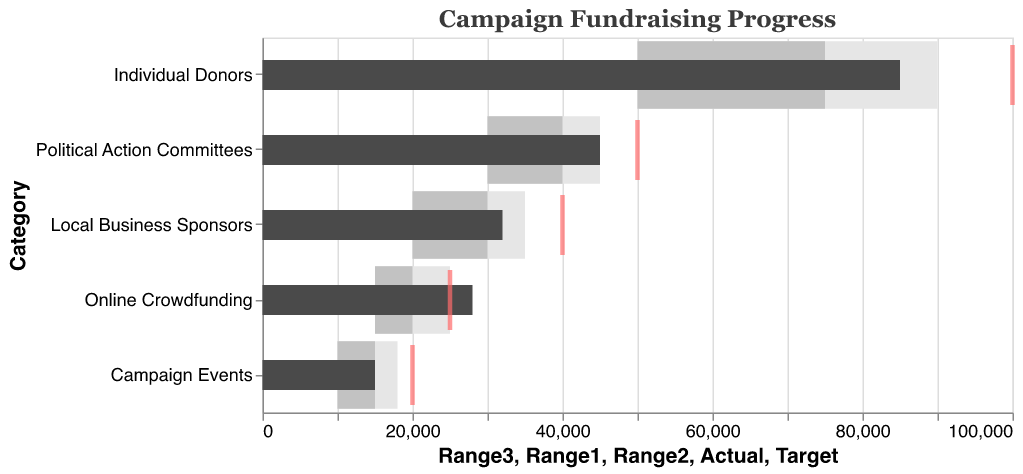What's the overall title of the chart? The title of the chart is displayed at the top and provides a summary of the displayed data. It reads "Campaign Fundraising Progress."
Answer: Campaign Fundraising Progress What color is used for representing the "Actual" values in the chart? The "Actual" values are displayed as bars with a dark shade. Specifically, they are represented with a dark gray color.
Answer: Dark gray Which donation source has the highest actual fundraising amount? By comparing the lengths of the dark gray bars, we can see that "Individual Donors" has the longest bar, indicating the highest actual fundraising amount of 85,000.
Answer: Individual Donors Did "Online Crowdfunding" exceed its target? The actual value bar for "Online Crowdfunding" exceeds the target position marked by the red tick, suggesting that it did exceed its target.
Answer: Yes How many donation sources have actual amounts above their "Range3" values? By looking at the bars and comparing them with the "Range3" values, "Online Crowdfunding" and "Individual Donors" have actual amounts above their "Range3" values.
Answer: Two What is the difference between the actual and target values for "Political Action Committees"? The difference is calculated by subtracting the target value from the actual value: 45000 (Actual) - 50000 (Target) = -5000.
Answer: -5000 Which donation source has the closest actual fundraising amount to its target? By comparing the positions of the dark gray bars with their respective red ticks, "Online Crowdfunding" appears to be almost aligned with the target, making it have the closest actual amount to its target.
Answer: Online Crowdfunding Among the donation sources, which one has the largest difference between "Range2" and "Range1"? To find this, we need to check the difference for each category: "Individual Donors" (75000 - 50000 = 25000), "Local Business Sponsors" (30000 - 20000 = 10000), "Online Crowdfunding" (20000 - 15000 = 5000), "Campaign Events" (15000 - 10000 = 5000), and "Political Action Committees" (40000 - 30000 = 10000). The largest difference is for "Individual Donors."
Answer: Individual Donors Based on the ranges, which donation source has the most challenging (narrowest) target range from Range1 to Range3? "Campaign Events" has the narrowest range from Range1 (10,000) to Range3 (18,000), a range of 8,000, which is the smallest amongst all categories.
Answer: Campaign Events 